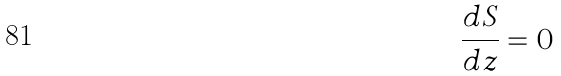Convert formula to latex. <formula><loc_0><loc_0><loc_500><loc_500>\frac { d S } { d z } = 0</formula> 